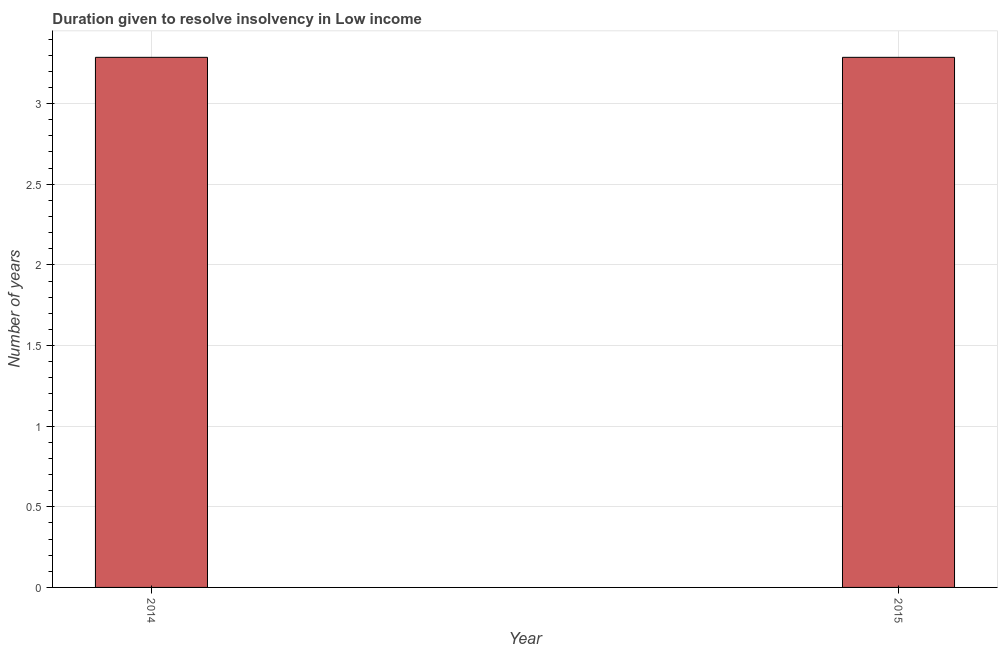Does the graph contain any zero values?
Provide a succinct answer. No. What is the title of the graph?
Make the answer very short. Duration given to resolve insolvency in Low income. What is the label or title of the X-axis?
Your answer should be compact. Year. What is the label or title of the Y-axis?
Give a very brief answer. Number of years. What is the number of years to resolve insolvency in 2015?
Offer a terse response. 3.29. Across all years, what is the maximum number of years to resolve insolvency?
Make the answer very short. 3.29. Across all years, what is the minimum number of years to resolve insolvency?
Ensure brevity in your answer.  3.29. In which year was the number of years to resolve insolvency maximum?
Offer a very short reply. 2014. What is the sum of the number of years to resolve insolvency?
Provide a short and direct response. 6.57. What is the difference between the number of years to resolve insolvency in 2014 and 2015?
Offer a very short reply. 0. What is the average number of years to resolve insolvency per year?
Your answer should be very brief. 3.29. What is the median number of years to resolve insolvency?
Provide a short and direct response. 3.29. How many bars are there?
Make the answer very short. 2. What is the Number of years of 2014?
Your answer should be compact. 3.29. What is the Number of years in 2015?
Provide a succinct answer. 3.29. 